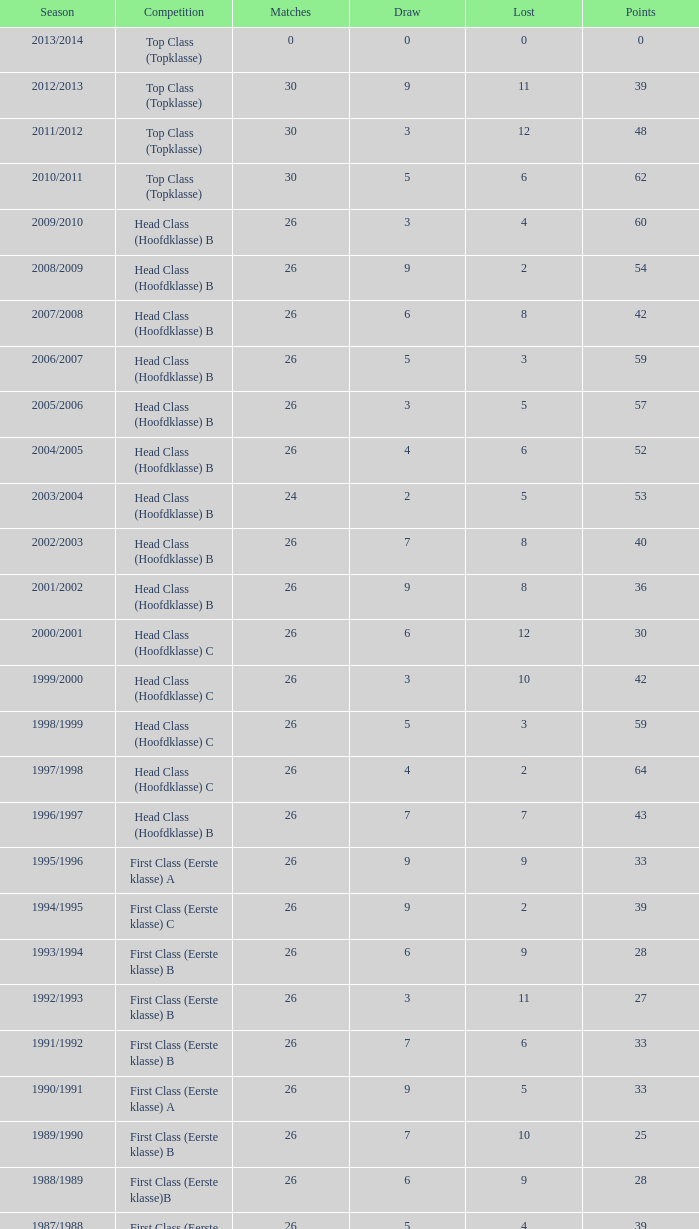In the 2008/2009 season, what is the cumulative number of fixtures with a loss fewer than 5 and a stalemate exceeding 9? 0.0. 